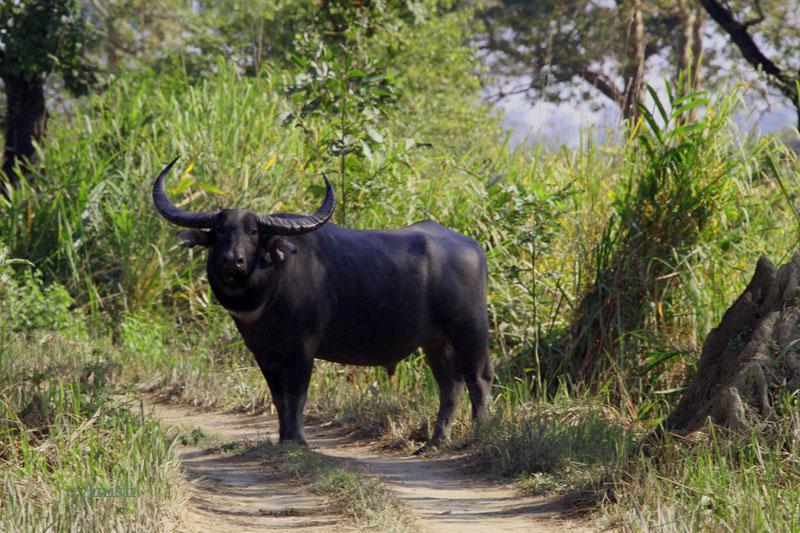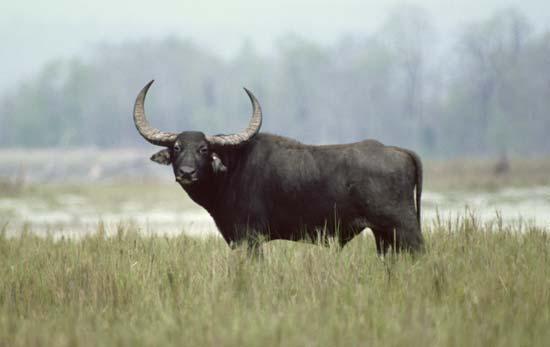The first image is the image on the left, the second image is the image on the right. For the images shown, is this caption "There are exactly three animals in each set of images." true? Answer yes or no. No. The first image is the image on the left, the second image is the image on the right. Evaluate the accuracy of this statement regarding the images: "One image shows exactly two water buffalo, both in profile.". Is it true? Answer yes or no. No. 